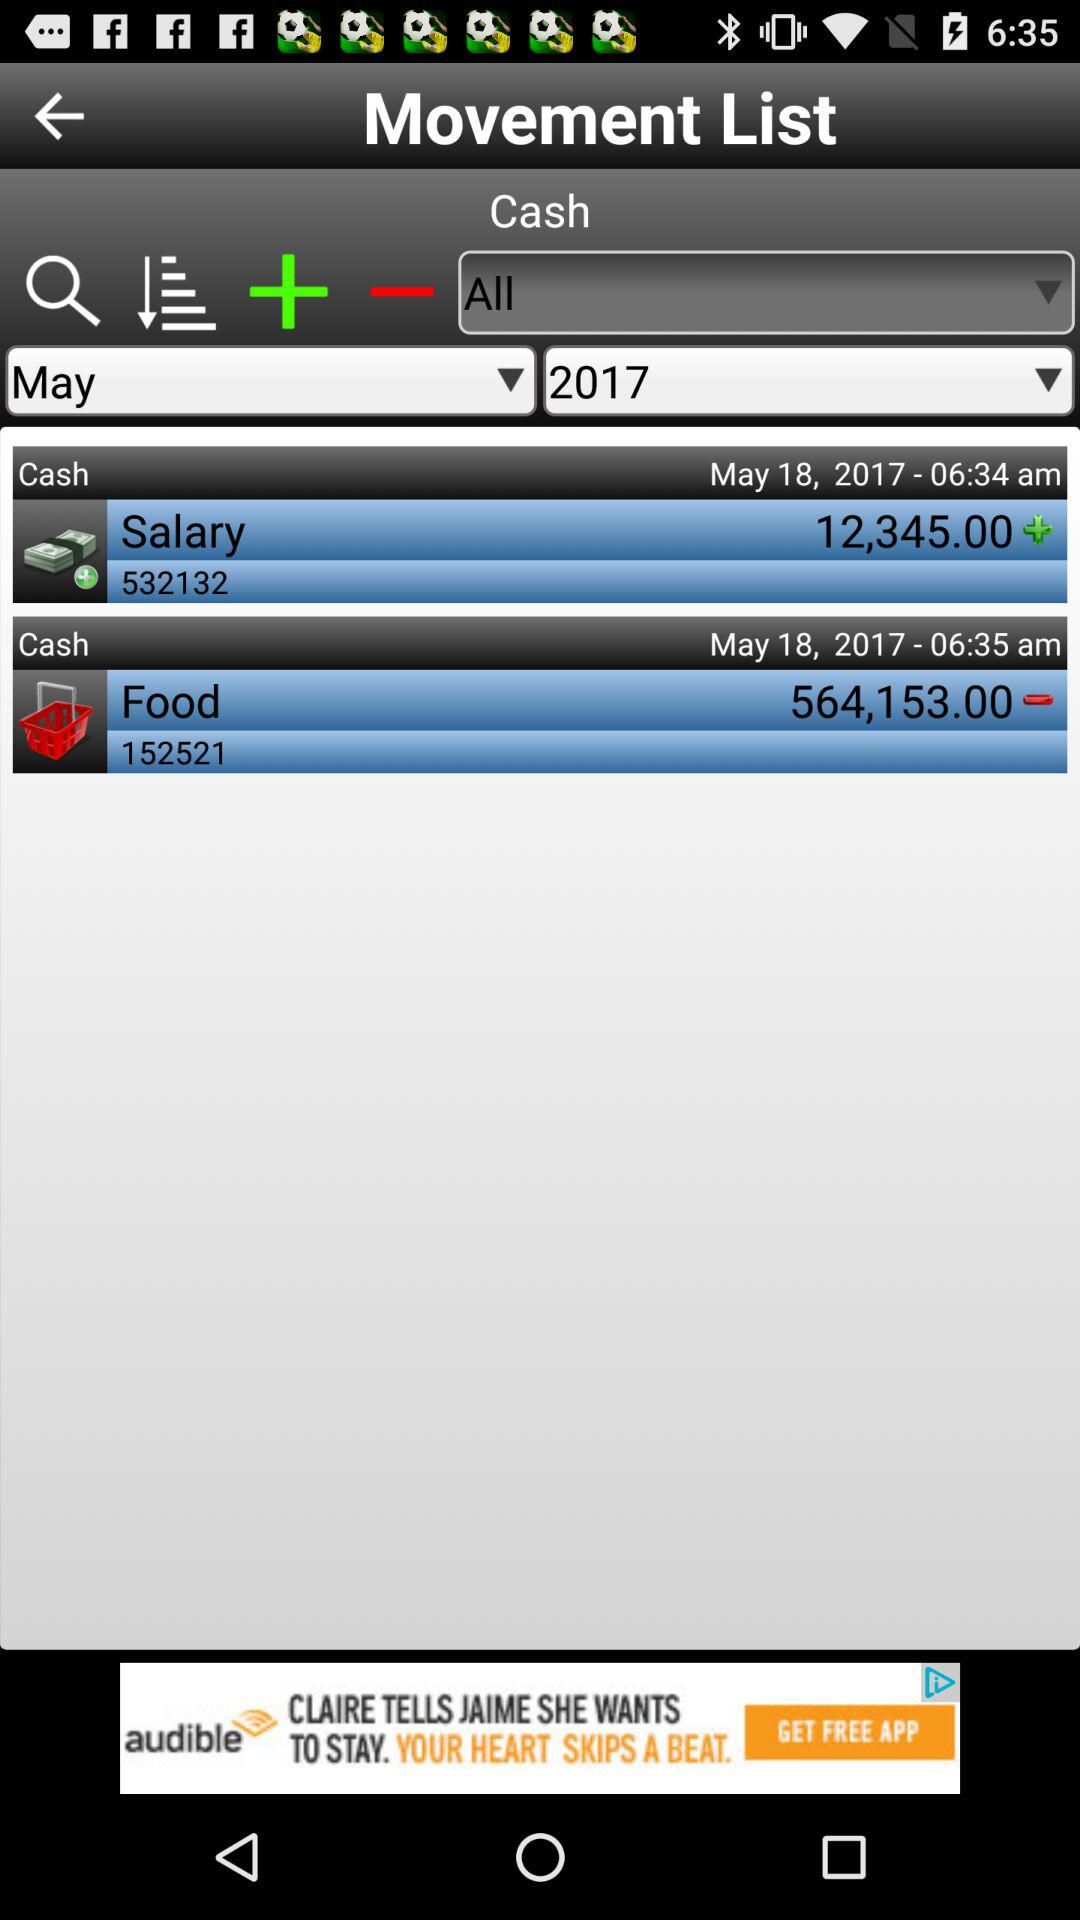What's the salary amount credited to the account? The salary amount credited to the account is 12,345. 